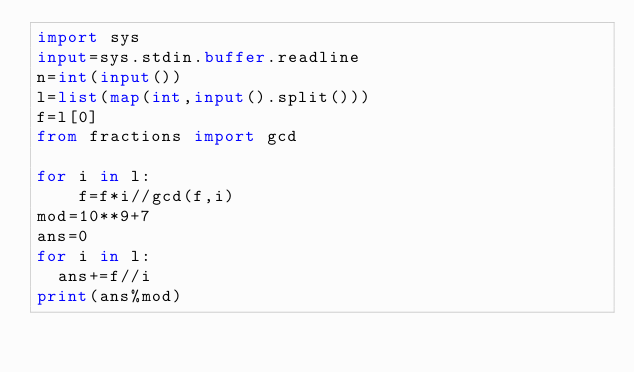<code> <loc_0><loc_0><loc_500><loc_500><_Python_>import sys
input=sys.stdin.buffer.readline
n=int(input())
l=list(map(int,input().split()))
f=l[0]
from fractions import gcd

for i in l:
    f=f*i//gcd(f,i)
mod=10**9+7
ans=0
for i in l:
  ans+=f//i
print(ans%mod)
</code> 